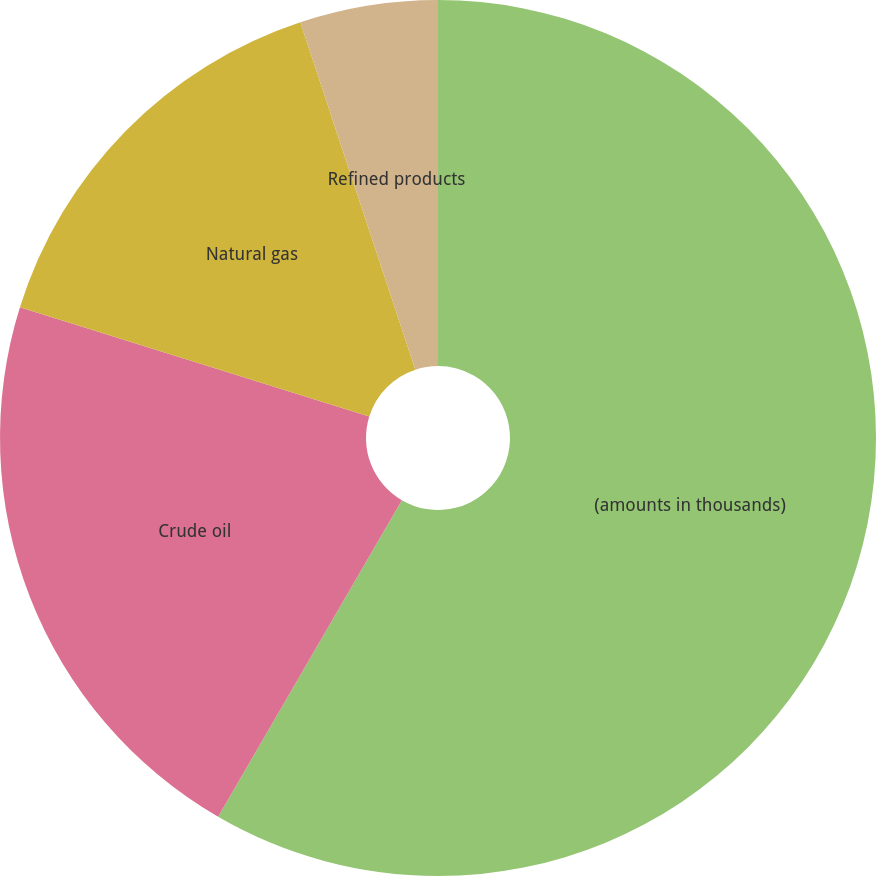Convert chart to OTSL. <chart><loc_0><loc_0><loc_500><loc_500><pie_chart><fcel>(amounts in thousands)<fcel>Crude oil<fcel>Natural gas<fcel>Refined products<nl><fcel>58.37%<fcel>21.45%<fcel>15.09%<fcel>5.09%<nl></chart> 